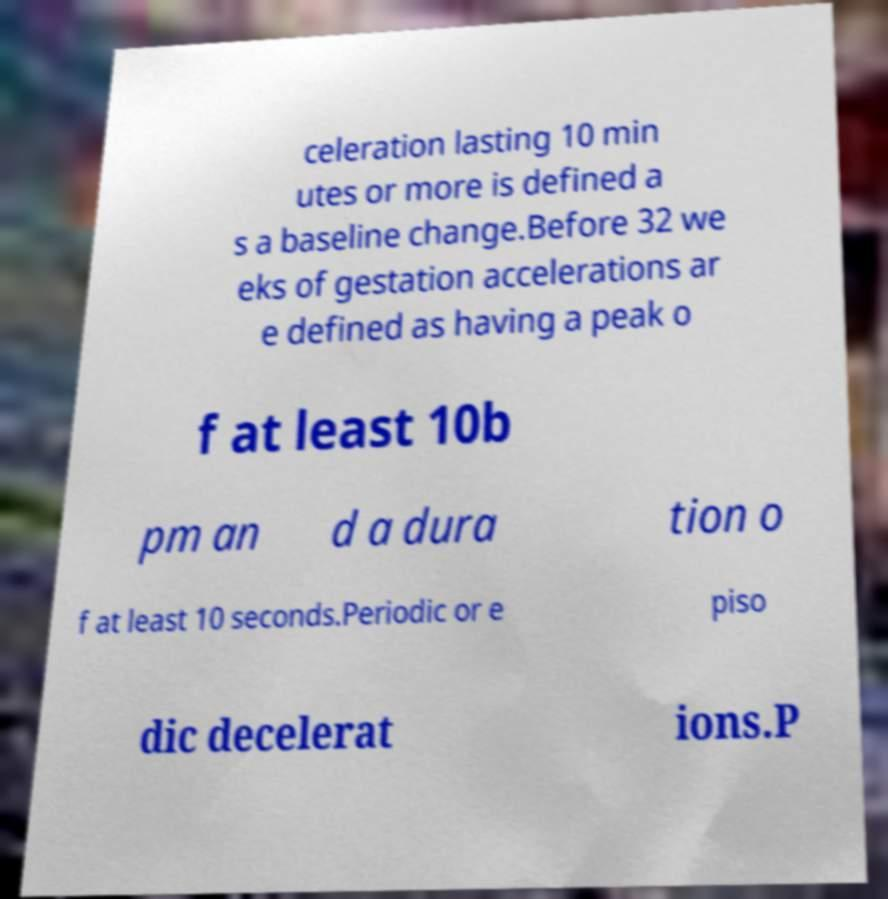Could you extract and type out the text from this image? celeration lasting 10 min utes or more is defined a s a baseline change.Before 32 we eks of gestation accelerations ar e defined as having a peak o f at least 10b pm an d a dura tion o f at least 10 seconds.Periodic or e piso dic decelerat ions.P 